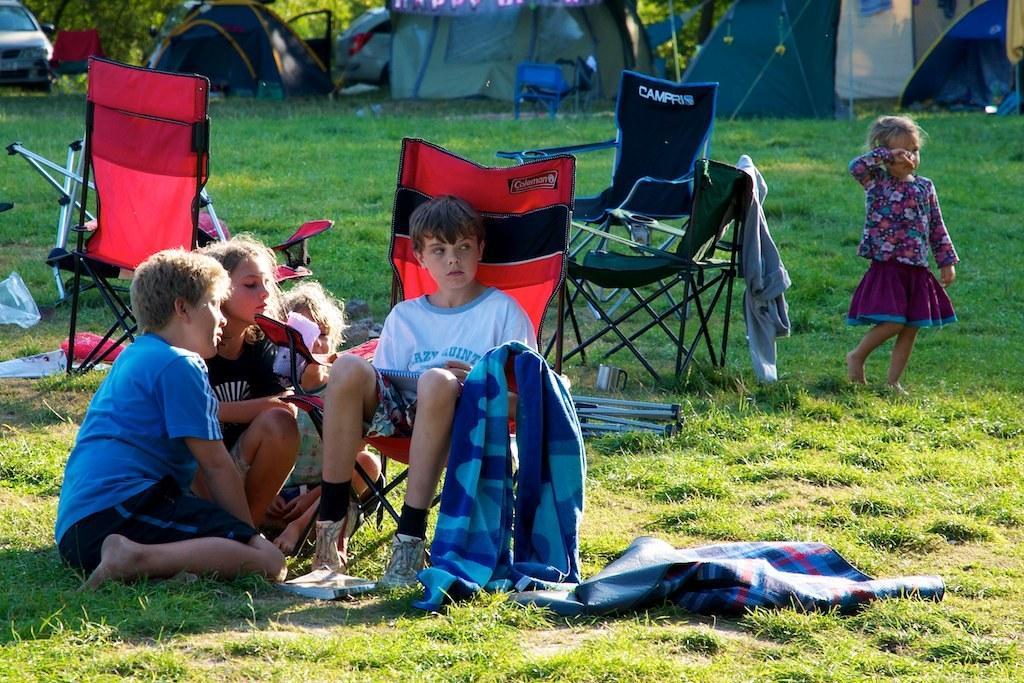How would you summarize this image in a sentence or two? On the left 3 children are sitting. In the middle a boy is sitting in the chair right girl is walking behind them there are tents and vehicles. 